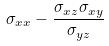Convert formula to latex. <formula><loc_0><loc_0><loc_500><loc_500>\sigma _ { x x } - \frac { \sigma _ { x z } \sigma _ { x y } } { \sigma _ { y z } }</formula> 